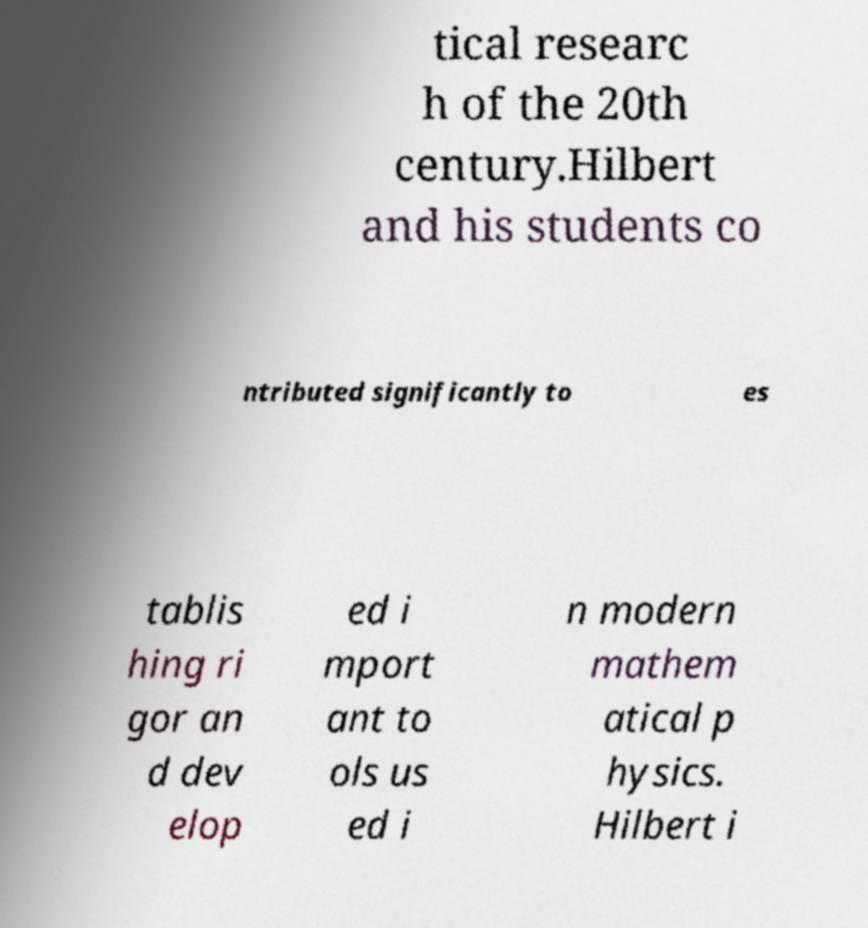Can you accurately transcribe the text from the provided image for me? tical researc h of the 20th century.Hilbert and his students co ntributed significantly to es tablis hing ri gor an d dev elop ed i mport ant to ols us ed i n modern mathem atical p hysics. Hilbert i 